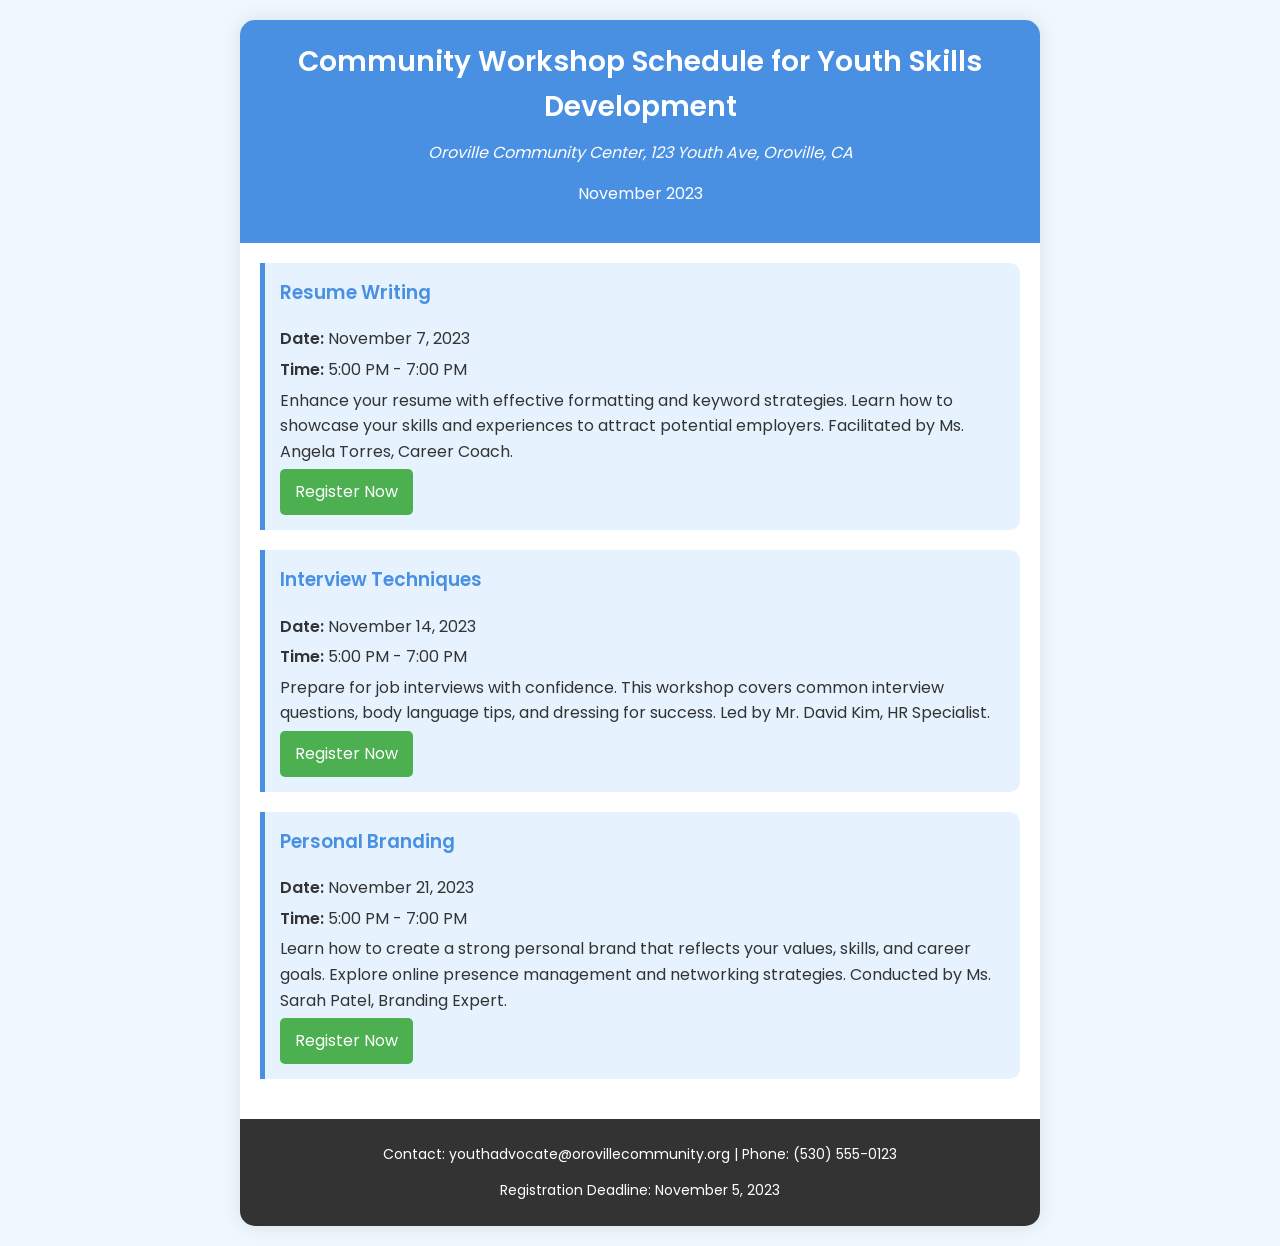what is the location of the workshops? The workshops are scheduled to be held at the Oroville Community Center located at 123 Youth Ave, Oroville, CA.
Answer: Oroville Community Center, 123 Youth Ave, Oroville, CA what is the first workshop date? The first workshop in the schedule is for Resume Writing on November 7, 2023.
Answer: November 7, 2023 how long is each workshop session? Each workshop session is scheduled to last for 2 hours, from 5:00 PM to 7:00 PM.
Answer: 2 hours who is the facilitator for the Interview Techniques workshop? The facilitator for the Interview Techniques workshop is Mr. David Kim, who is an HR Specialist.
Answer: Mr. David Kim how many workshops are there in November 2023? There are a total of three workshops scheduled in November 2023.
Answer: three what is the registration deadline for the workshops? The registration deadline for the workshops is specifically mentioned in the footer of the document.
Answer: November 5, 2023 what is the topic of the second workshop? The second workshop is focused on Interview Techniques as indicated in the schedule.
Answer: Interview Techniques who conducts the Personal Branding workshop? The Personal Branding workshop is conducted by Ms. Sarah Patel, a Branding Expert.
Answer: Ms. Sarah Patel 